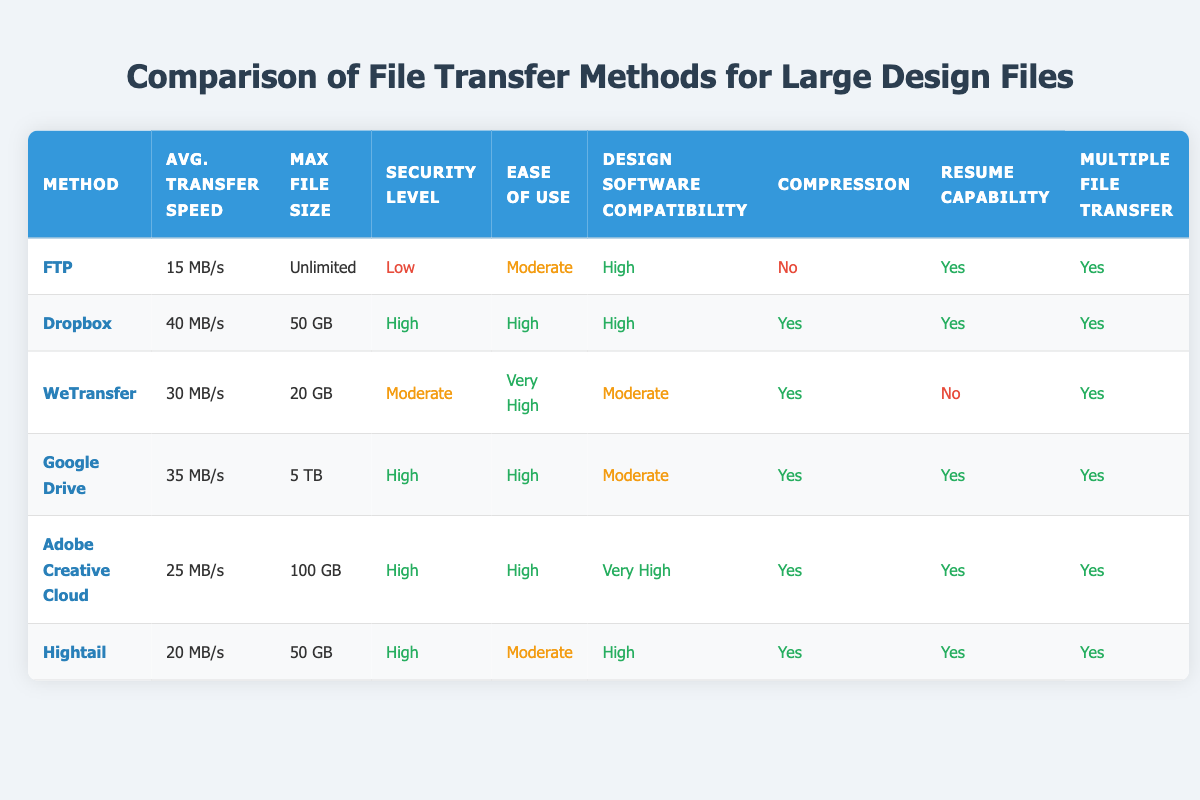What is the average transfer speed of Dropbox? The table lists Dropbox's average transfer speed as 40 MB/s.
Answer: 40 MB/s Which file transfer method supports the largest file size? According to the table, Google Drive supports a maximum file size of 5 TB, which is larger than the limits of the other methods listed.
Answer: Google Drive Does WeTransfer have a resume capability? The table indicates that WeTransfer does not have resume capability as it is marked "No."
Answer: No What is the security level of FTP? The table shows that FTP has a security level labeled "Low."
Answer: Low Which file transfer method has the highest average transfer speed and supports multiple file transfers? Dropbox has the highest average transfer speed of 40 MB/s and has "Yes" marked for multiple file transfers, making it the best option by these criteria.
Answer: Dropbox Is Adobe Creative Cloud compatible with design software? The compatibility level for Adobe Creative Cloud is labeled "Very High," indicating it is suitable for design software.
Answer: Yes If you compare the average transfer speeds of Google Drive and Hightail, how much faster is Google Drive? The average transfer speed of Google Drive is 35 MB/s, while Hightail is 20 MB/s. The difference is calculated as 35 - 20 = 15.
Answer: 15 MB/s Which methods have a high security level? Both Dropbox, Google Drive, and Adobe Creative Cloud are marked with a high security level in the table.
Answer: Dropbox, Google Drive, Adobe Creative Cloud Are there any file transfer methods that do not support compression? The table shows that FTP is the only method listed that does not support compression, as it is marked "No."
Answer: Yes, FTP 